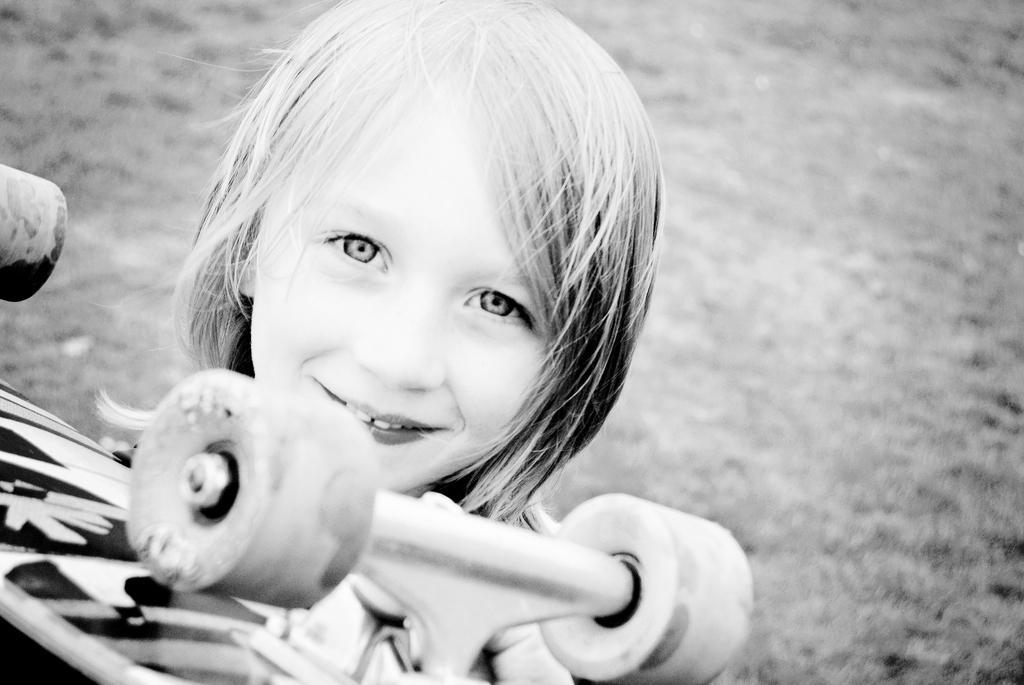Could you give a brief overview of what you see in this image? In front of the image there is a child holding some object. 